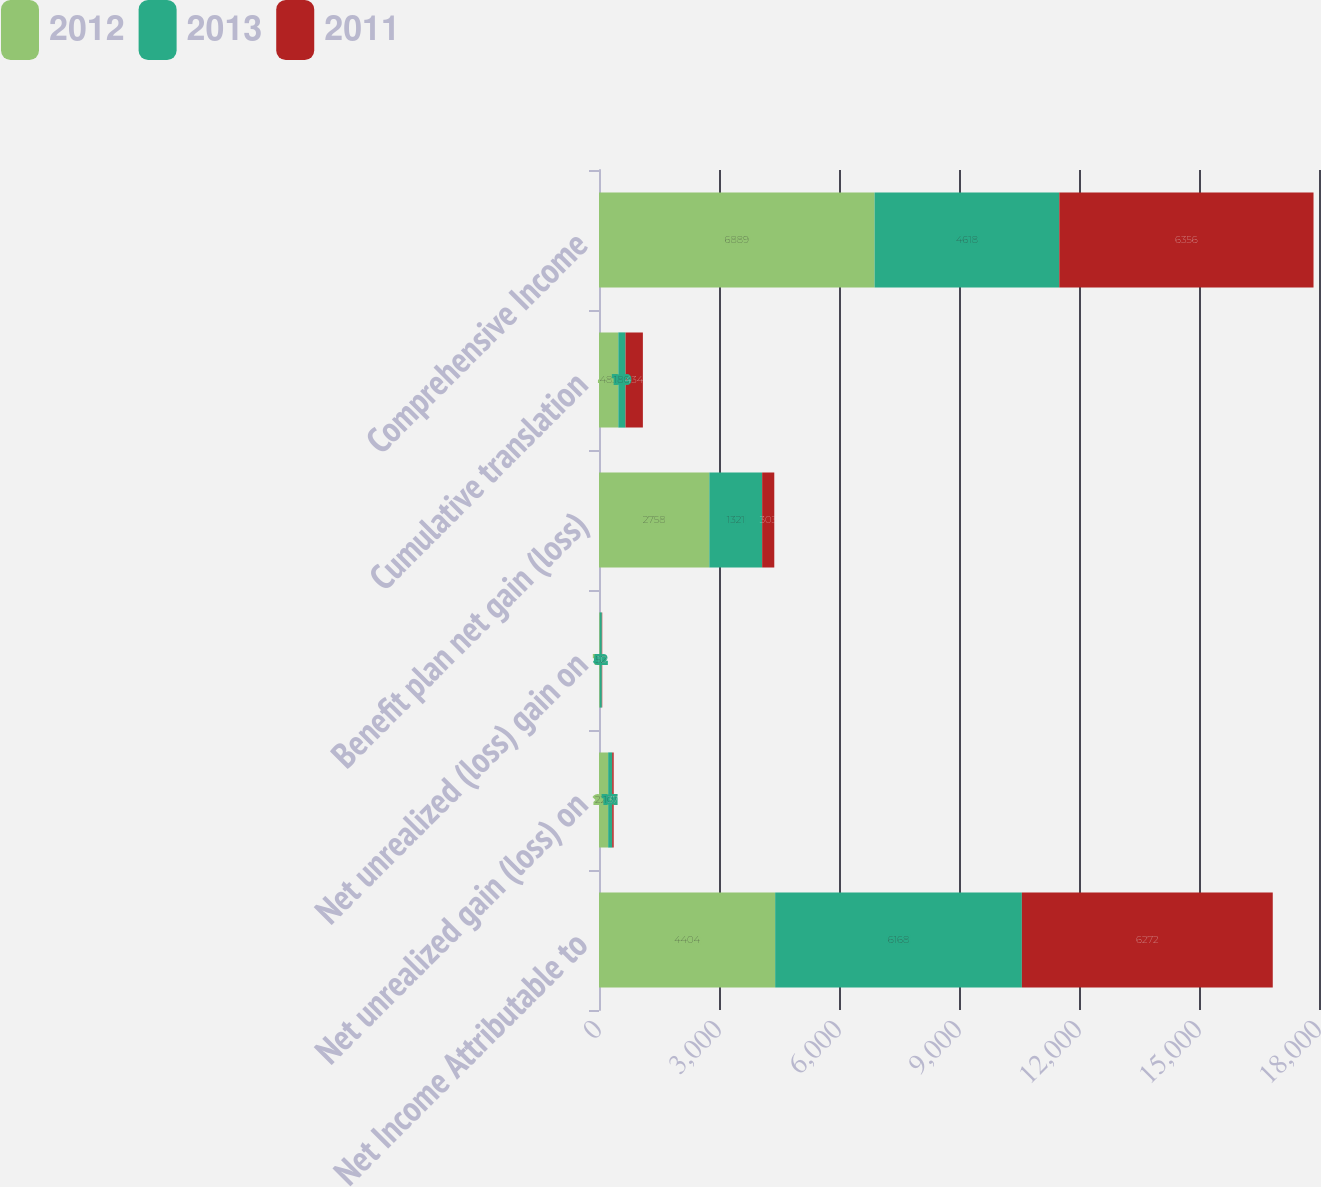Convert chart. <chart><loc_0><loc_0><loc_500><loc_500><stacked_bar_chart><ecel><fcel>Net Income Attributable to<fcel>Net unrealized gain (loss) on<fcel>Net unrealized (loss) gain on<fcel>Benefit plan net gain (loss)<fcel>Cumulative translation<fcel>Comprehensive Income<nl><fcel>2012<fcel>4404<fcel>229<fcel>19<fcel>2758<fcel>483<fcel>6889<nl><fcel>2013<fcel>6168<fcel>101<fcel>52<fcel>1321<fcel>180<fcel>4618<nl><fcel>2011<fcel>6272<fcel>37<fcel>10<fcel>303<fcel>434<fcel>6356<nl></chart> 